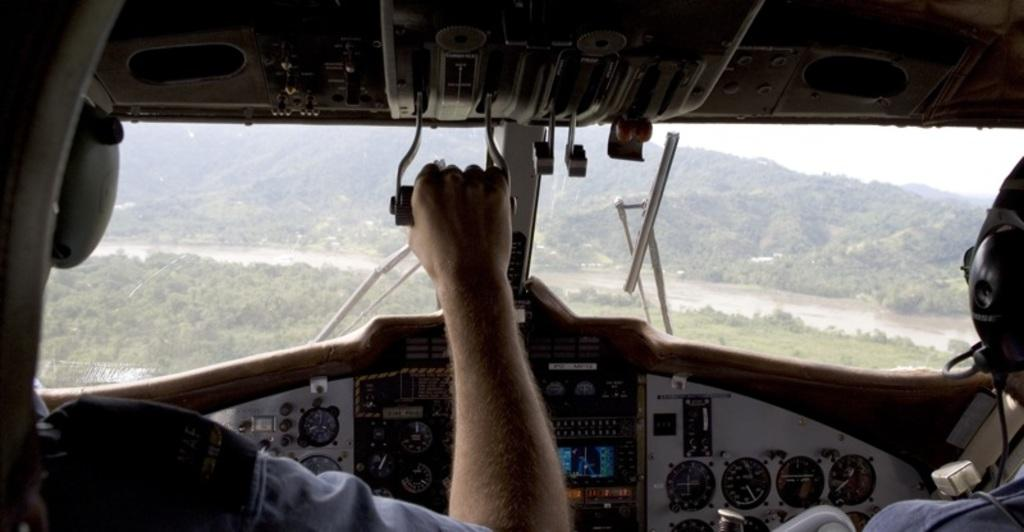How many pilots are in the image? There are two pilots in the image. What is one person holding in the image? One person is holding an object. What can be seen in the background of the image? There are trees and mountains in the background of the image. What is the condition of the sky in the image? The sky is clear in the image. What type of toothpaste is visible in the image? There is no toothpaste present in the image. How do the pilots' feet look in the image? The image does not show the pilots' feet, so it cannot be determined how they look. 